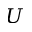<formula> <loc_0><loc_0><loc_500><loc_500>U</formula> 